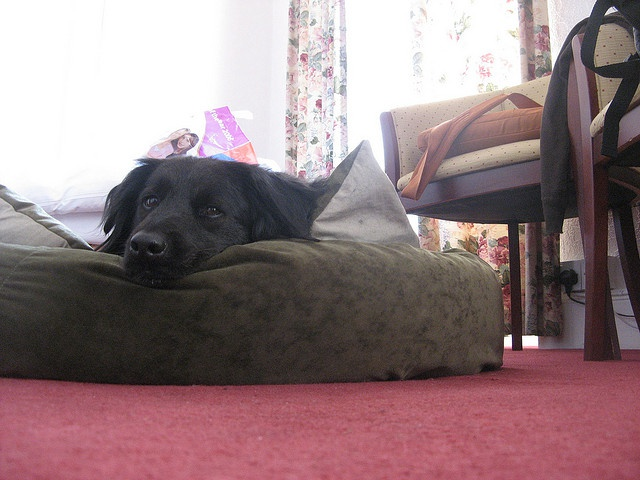Describe the objects in this image and their specific colors. I can see bed in white, black, gray, and darkgray tones, chair in white, black, gray, and darkgray tones, and dog in white, black, and gray tones in this image. 